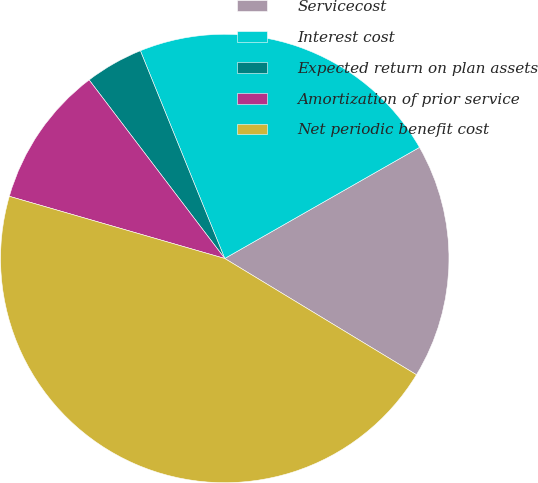Convert chart. <chart><loc_0><loc_0><loc_500><loc_500><pie_chart><fcel>Servicecost<fcel>Interest cost<fcel>Expected return on plan assets<fcel>Amortization of prior service<fcel>Net periodic benefit cost<nl><fcel>16.93%<fcel>22.89%<fcel>4.2%<fcel>10.19%<fcel>45.8%<nl></chart> 